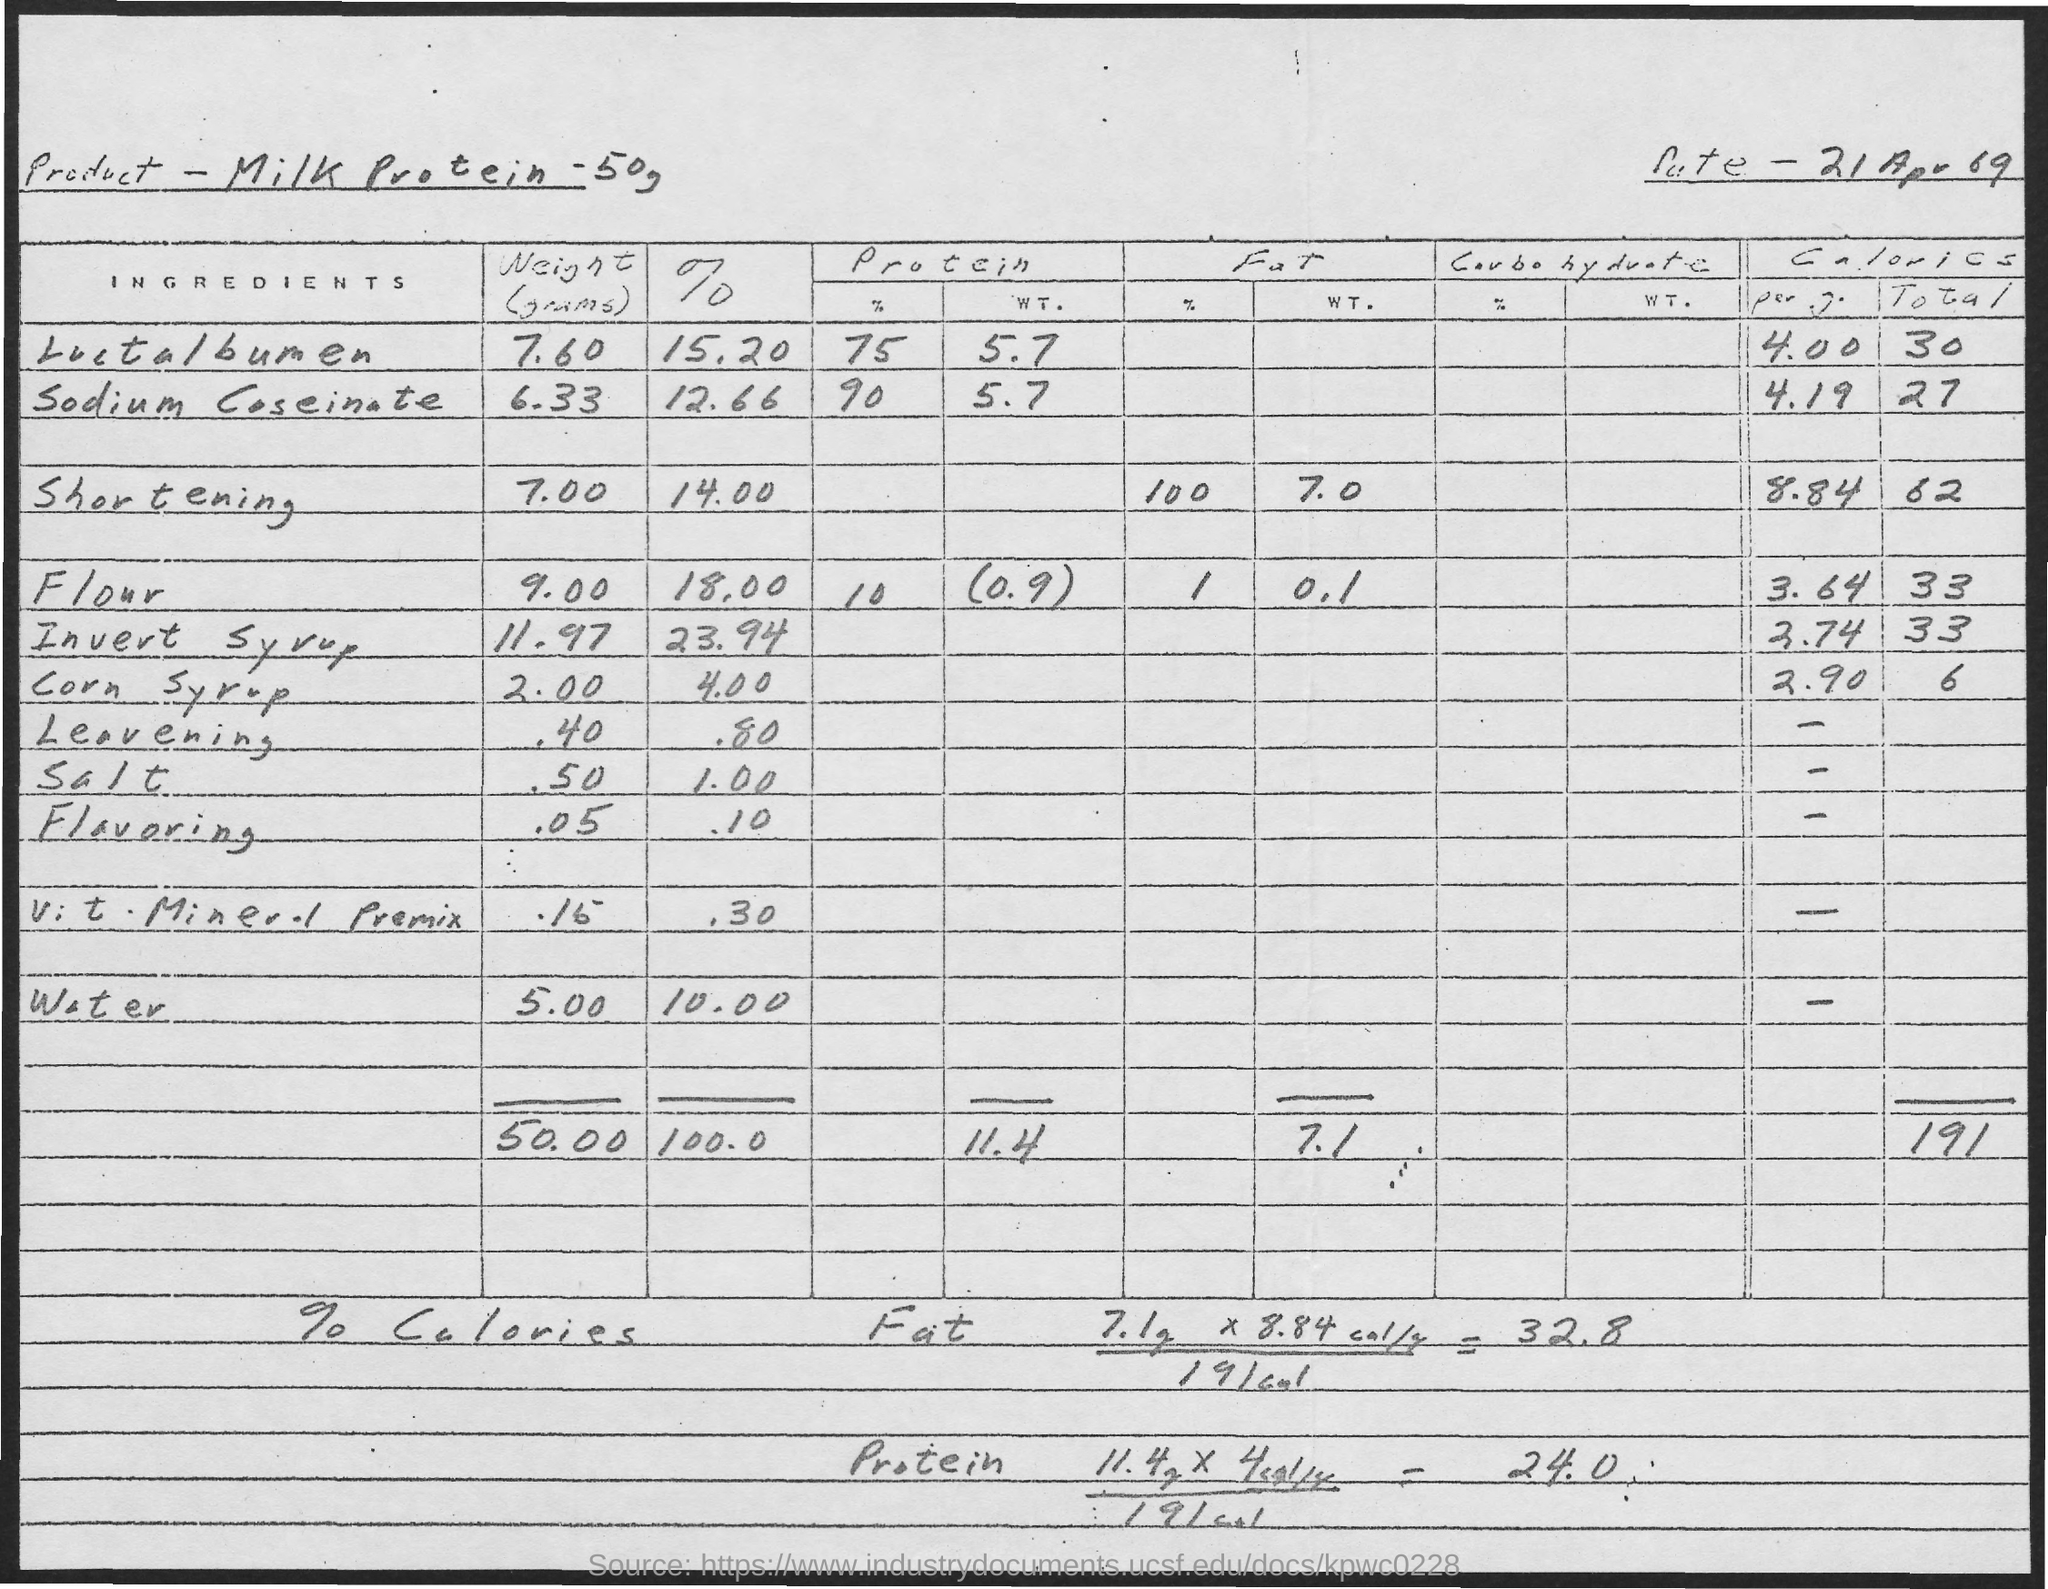What is the weight of corn syrup? In the provided image, which appears to be an old handwritten document detailing a recipe, the weight of corn syrup used is listed as 2.00 grams. 